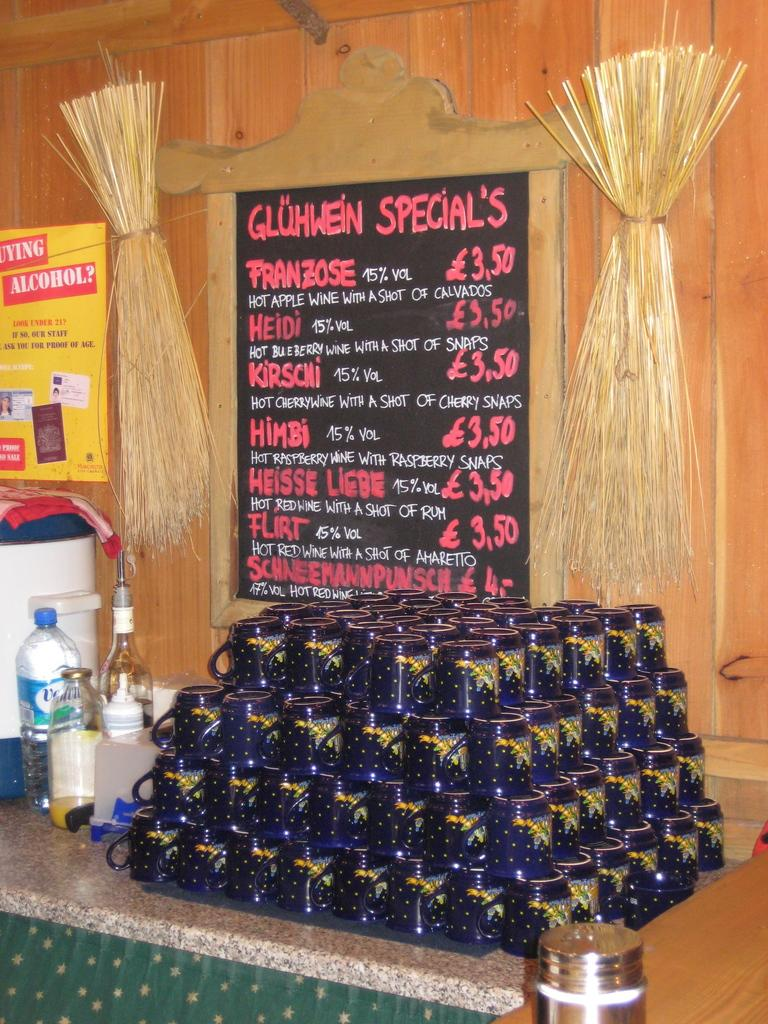<image>
Provide a brief description of the given image. A stack of blue mugs in front of a sign advertising the day's specials. 